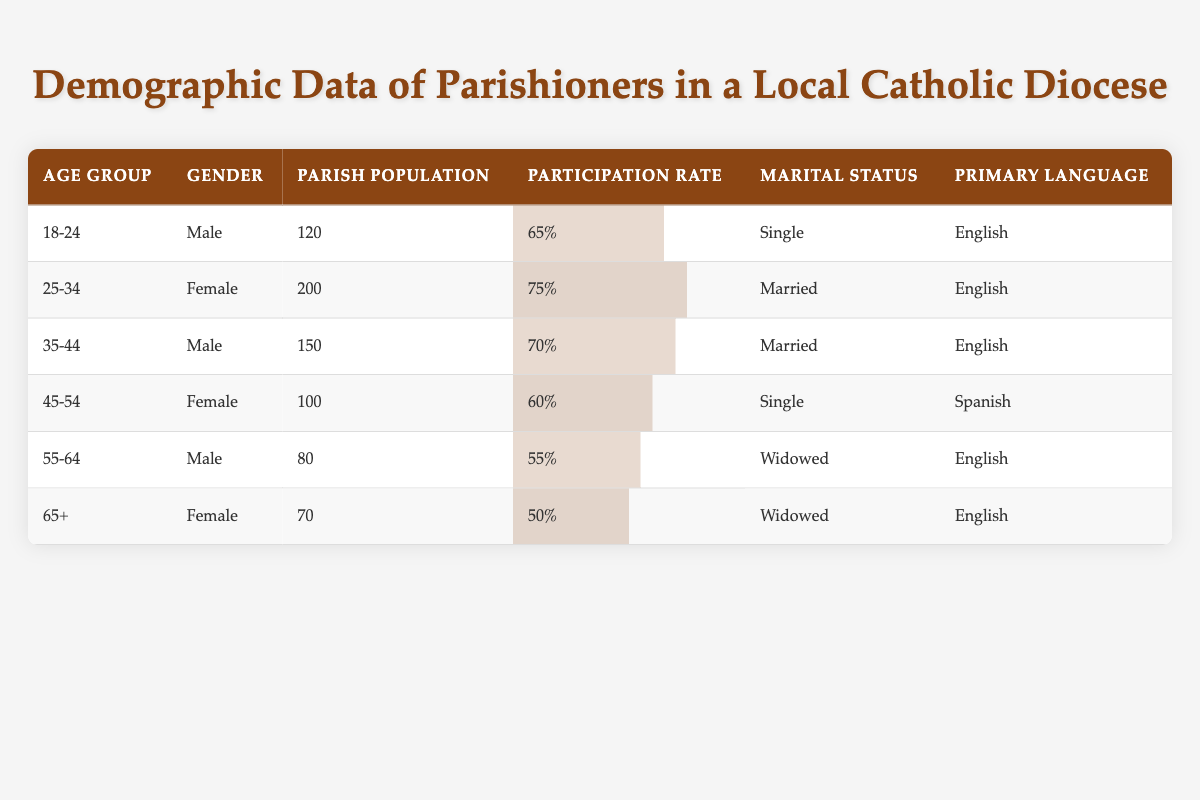What is the participation rate for the 18-24 age group? The participation rate for this age group is provided in the table under the "Participation Rate" column for the row corresponding to age group "18-24." It is listed as 65%.
Answer: 65% Which age group has the highest parish population? By reviewing the "Parish Population" column, the age group "25-34" has the highest value of 200 in the table.
Answer: 25-34 How many male parishioners are there aged 55-64? The table lists the parish population for the age group "55-64" with the gender "Male" as 80. So, there are 80 male parishioners in this age group.
Answer: 80 What is the average participation rate of all age groups? The participation rates from the table are: 65, 75, 70, 60, 55, and 50. Adding these gives 65 + 75 + 70 + 60 + 55 + 50 = 375. Then, dividing by the number of age groups (6) gives 375 / 6 = 62.5.
Answer: 62.5 Is there any age group with female parishioners that has a participation rate below 60%? Reviewing the participation rates for female parishioners listed under the relevant age groups, "45-54" has a participation rate of 60%, and "65+" has a participation rate of 50%. Therefore, "65+" does indeed have a participation rate below 60%.
Answer: Yes Which age group has the lowest participation rate, and what is that rate? By examining the participation rates in the table, the lowest rate is found for the age group "65+" at 50%. Therefore, "65+" has the lowest participation rate.
Answer: 65+, 50% What language is most commonly spoken by the widowed parishioners? Looking at the rows for widowed parishioners, both "55-64" and "65+" age groups have a primary language of "English." Thus, the most common language for widowed parishioners is English.
Answer: English How many parishioners in the age group 45-54 are single? In the row for the age group "45-54," the marital status is listed as "Single," with a parish population of 100. Therefore, there are 100 single parishioners in this age group.
Answer: 100 Which gender has a higher participation rate in the age group 35-44? In the age group "35-44," the participation rate for males is 70%. There is no female representation in this age group, as it only lists males. Therefore, the answer is males.
Answer: Male Are there more married parishioners aged 25-34 or more male parishioners in the age group 18-24? For "25-34," there are 200 married parishioners, and for "18-24," there are 120 male parishioners. As 200 is greater than 120, there are more married parishioners aged 25-34.
Answer: 25-34 (200) 